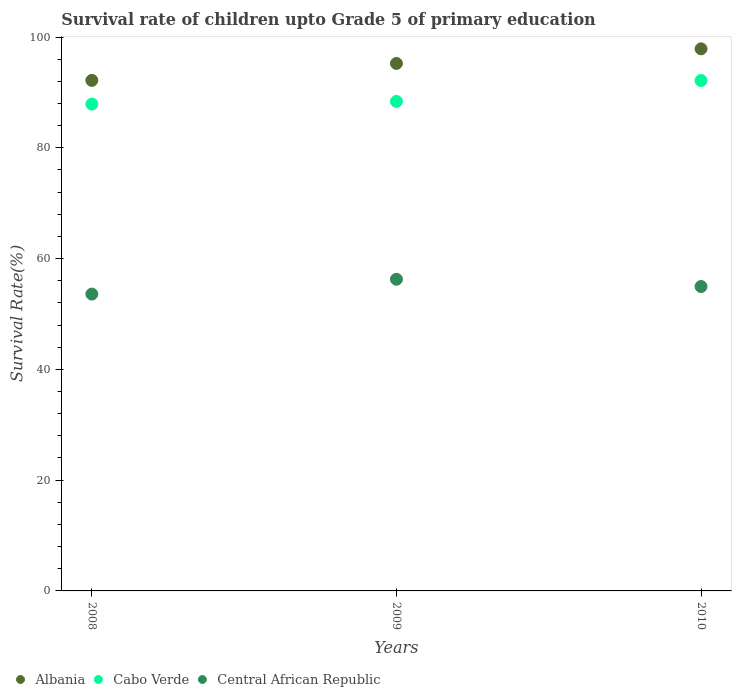How many different coloured dotlines are there?
Offer a terse response. 3. What is the survival rate of children in Cabo Verde in 2010?
Offer a very short reply. 92.15. Across all years, what is the maximum survival rate of children in Cabo Verde?
Your answer should be very brief. 92.15. Across all years, what is the minimum survival rate of children in Albania?
Your answer should be compact. 92.17. In which year was the survival rate of children in Albania maximum?
Keep it short and to the point. 2010. What is the total survival rate of children in Cabo Verde in the graph?
Keep it short and to the point. 268.41. What is the difference between the survival rate of children in Albania in 2009 and that in 2010?
Provide a short and direct response. -2.64. What is the difference between the survival rate of children in Cabo Verde in 2008 and the survival rate of children in Central African Republic in 2009?
Ensure brevity in your answer.  31.62. What is the average survival rate of children in Albania per year?
Offer a very short reply. 95.09. In the year 2009, what is the difference between the survival rate of children in Cabo Verde and survival rate of children in Central African Republic?
Make the answer very short. 32.11. In how many years, is the survival rate of children in Cabo Verde greater than 80 %?
Give a very brief answer. 3. What is the ratio of the survival rate of children in Cabo Verde in 2009 to that in 2010?
Offer a very short reply. 0.96. Is the survival rate of children in Cabo Verde in 2008 less than that in 2009?
Provide a succinct answer. Yes. Is the difference between the survival rate of children in Cabo Verde in 2008 and 2010 greater than the difference between the survival rate of children in Central African Republic in 2008 and 2010?
Offer a very short reply. No. What is the difference between the highest and the second highest survival rate of children in Central African Republic?
Your response must be concise. 1.31. What is the difference between the highest and the lowest survival rate of children in Albania?
Provide a succinct answer. 5.69. In how many years, is the survival rate of children in Albania greater than the average survival rate of children in Albania taken over all years?
Provide a short and direct response. 2. Does the survival rate of children in Albania monotonically increase over the years?
Provide a succinct answer. Yes. Is the survival rate of children in Central African Republic strictly less than the survival rate of children in Cabo Verde over the years?
Your answer should be very brief. Yes. How many years are there in the graph?
Your response must be concise. 3. What is the difference between two consecutive major ticks on the Y-axis?
Your response must be concise. 20. Are the values on the major ticks of Y-axis written in scientific E-notation?
Make the answer very short. No. How are the legend labels stacked?
Provide a short and direct response. Horizontal. What is the title of the graph?
Your answer should be compact. Survival rate of children upto Grade 5 of primary education. What is the label or title of the Y-axis?
Give a very brief answer. Survival Rate(%). What is the Survival Rate(%) in Albania in 2008?
Your answer should be compact. 92.17. What is the Survival Rate(%) of Cabo Verde in 2008?
Provide a succinct answer. 87.89. What is the Survival Rate(%) of Central African Republic in 2008?
Offer a terse response. 53.59. What is the Survival Rate(%) in Albania in 2009?
Make the answer very short. 95.23. What is the Survival Rate(%) of Cabo Verde in 2009?
Offer a very short reply. 88.38. What is the Survival Rate(%) of Central African Republic in 2009?
Offer a very short reply. 56.27. What is the Survival Rate(%) in Albania in 2010?
Keep it short and to the point. 97.86. What is the Survival Rate(%) of Cabo Verde in 2010?
Your answer should be very brief. 92.15. What is the Survival Rate(%) of Central African Republic in 2010?
Ensure brevity in your answer.  54.95. Across all years, what is the maximum Survival Rate(%) in Albania?
Offer a very short reply. 97.86. Across all years, what is the maximum Survival Rate(%) of Cabo Verde?
Your response must be concise. 92.15. Across all years, what is the maximum Survival Rate(%) in Central African Republic?
Your answer should be very brief. 56.27. Across all years, what is the minimum Survival Rate(%) in Albania?
Offer a terse response. 92.17. Across all years, what is the minimum Survival Rate(%) of Cabo Verde?
Make the answer very short. 87.89. Across all years, what is the minimum Survival Rate(%) of Central African Republic?
Provide a succinct answer. 53.59. What is the total Survival Rate(%) in Albania in the graph?
Give a very brief answer. 285.26. What is the total Survival Rate(%) of Cabo Verde in the graph?
Your answer should be very brief. 268.41. What is the total Survival Rate(%) in Central African Republic in the graph?
Your response must be concise. 164.81. What is the difference between the Survival Rate(%) of Albania in 2008 and that in 2009?
Your answer should be compact. -3.06. What is the difference between the Survival Rate(%) in Cabo Verde in 2008 and that in 2009?
Keep it short and to the point. -0.49. What is the difference between the Survival Rate(%) of Central African Republic in 2008 and that in 2009?
Make the answer very short. -2.67. What is the difference between the Survival Rate(%) in Albania in 2008 and that in 2010?
Your answer should be compact. -5.69. What is the difference between the Survival Rate(%) in Cabo Verde in 2008 and that in 2010?
Ensure brevity in your answer.  -4.26. What is the difference between the Survival Rate(%) in Central African Republic in 2008 and that in 2010?
Your response must be concise. -1.36. What is the difference between the Survival Rate(%) of Albania in 2009 and that in 2010?
Your response must be concise. -2.64. What is the difference between the Survival Rate(%) in Cabo Verde in 2009 and that in 2010?
Your response must be concise. -3.77. What is the difference between the Survival Rate(%) in Central African Republic in 2009 and that in 2010?
Offer a terse response. 1.31. What is the difference between the Survival Rate(%) in Albania in 2008 and the Survival Rate(%) in Cabo Verde in 2009?
Keep it short and to the point. 3.79. What is the difference between the Survival Rate(%) in Albania in 2008 and the Survival Rate(%) in Central African Republic in 2009?
Provide a succinct answer. 35.9. What is the difference between the Survival Rate(%) of Cabo Verde in 2008 and the Survival Rate(%) of Central African Republic in 2009?
Give a very brief answer. 31.62. What is the difference between the Survival Rate(%) in Albania in 2008 and the Survival Rate(%) in Cabo Verde in 2010?
Your response must be concise. 0.02. What is the difference between the Survival Rate(%) in Albania in 2008 and the Survival Rate(%) in Central African Republic in 2010?
Your answer should be very brief. 37.22. What is the difference between the Survival Rate(%) of Cabo Verde in 2008 and the Survival Rate(%) of Central African Republic in 2010?
Provide a short and direct response. 32.94. What is the difference between the Survival Rate(%) in Albania in 2009 and the Survival Rate(%) in Cabo Verde in 2010?
Provide a succinct answer. 3.08. What is the difference between the Survival Rate(%) of Albania in 2009 and the Survival Rate(%) of Central African Republic in 2010?
Ensure brevity in your answer.  40.28. What is the difference between the Survival Rate(%) of Cabo Verde in 2009 and the Survival Rate(%) of Central African Republic in 2010?
Give a very brief answer. 33.42. What is the average Survival Rate(%) in Albania per year?
Keep it short and to the point. 95.09. What is the average Survival Rate(%) in Cabo Verde per year?
Your answer should be compact. 89.47. What is the average Survival Rate(%) in Central African Republic per year?
Ensure brevity in your answer.  54.94. In the year 2008, what is the difference between the Survival Rate(%) of Albania and Survival Rate(%) of Cabo Verde?
Your response must be concise. 4.28. In the year 2008, what is the difference between the Survival Rate(%) in Albania and Survival Rate(%) in Central African Republic?
Your answer should be compact. 38.58. In the year 2008, what is the difference between the Survival Rate(%) in Cabo Verde and Survival Rate(%) in Central African Republic?
Give a very brief answer. 34.3. In the year 2009, what is the difference between the Survival Rate(%) of Albania and Survival Rate(%) of Cabo Verde?
Offer a terse response. 6.85. In the year 2009, what is the difference between the Survival Rate(%) of Albania and Survival Rate(%) of Central African Republic?
Provide a short and direct response. 38.96. In the year 2009, what is the difference between the Survival Rate(%) in Cabo Verde and Survival Rate(%) in Central African Republic?
Provide a short and direct response. 32.11. In the year 2010, what is the difference between the Survival Rate(%) of Albania and Survival Rate(%) of Cabo Verde?
Your response must be concise. 5.72. In the year 2010, what is the difference between the Survival Rate(%) of Albania and Survival Rate(%) of Central African Republic?
Offer a very short reply. 42.91. In the year 2010, what is the difference between the Survival Rate(%) of Cabo Verde and Survival Rate(%) of Central African Republic?
Make the answer very short. 37.2. What is the ratio of the Survival Rate(%) of Albania in 2008 to that in 2009?
Provide a short and direct response. 0.97. What is the ratio of the Survival Rate(%) of Central African Republic in 2008 to that in 2009?
Your response must be concise. 0.95. What is the ratio of the Survival Rate(%) of Albania in 2008 to that in 2010?
Provide a short and direct response. 0.94. What is the ratio of the Survival Rate(%) of Cabo Verde in 2008 to that in 2010?
Provide a succinct answer. 0.95. What is the ratio of the Survival Rate(%) of Central African Republic in 2008 to that in 2010?
Your answer should be very brief. 0.98. What is the ratio of the Survival Rate(%) of Albania in 2009 to that in 2010?
Ensure brevity in your answer.  0.97. What is the ratio of the Survival Rate(%) in Cabo Verde in 2009 to that in 2010?
Keep it short and to the point. 0.96. What is the ratio of the Survival Rate(%) of Central African Republic in 2009 to that in 2010?
Provide a succinct answer. 1.02. What is the difference between the highest and the second highest Survival Rate(%) of Albania?
Offer a very short reply. 2.64. What is the difference between the highest and the second highest Survival Rate(%) of Cabo Verde?
Provide a succinct answer. 3.77. What is the difference between the highest and the second highest Survival Rate(%) in Central African Republic?
Your answer should be very brief. 1.31. What is the difference between the highest and the lowest Survival Rate(%) in Albania?
Provide a short and direct response. 5.69. What is the difference between the highest and the lowest Survival Rate(%) of Cabo Verde?
Your answer should be very brief. 4.26. What is the difference between the highest and the lowest Survival Rate(%) in Central African Republic?
Ensure brevity in your answer.  2.67. 